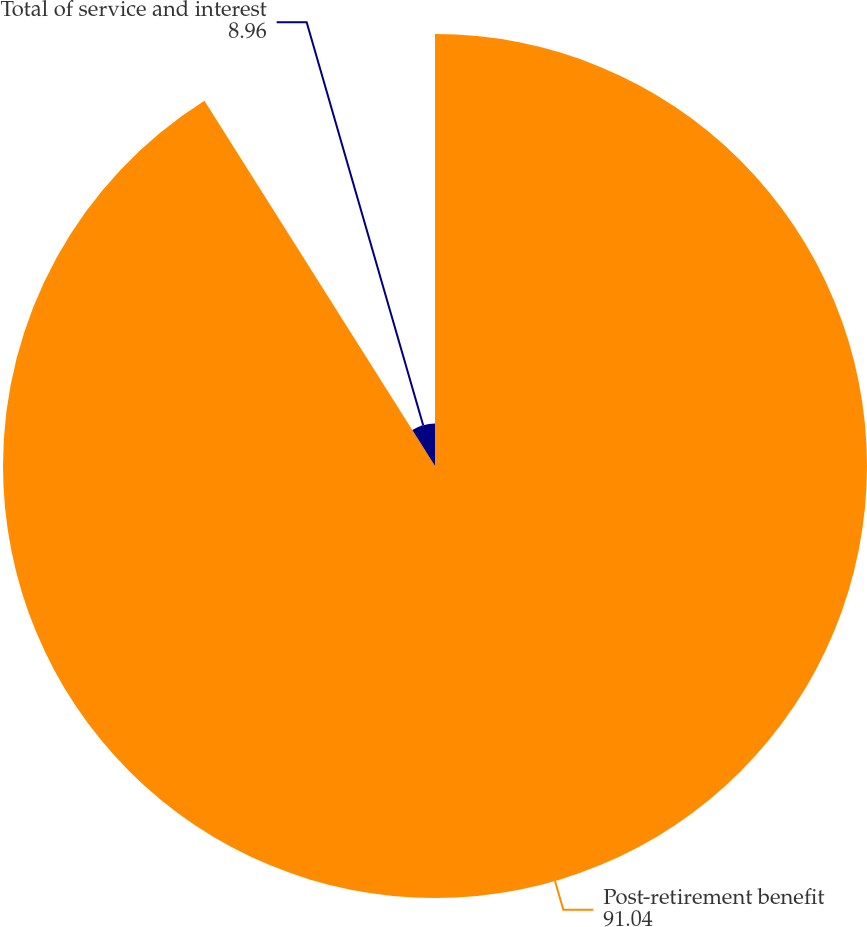Convert chart. <chart><loc_0><loc_0><loc_500><loc_500><pie_chart><fcel>Post-retirement benefit<fcel>Total of service and interest<nl><fcel>91.04%<fcel>8.96%<nl></chart> 